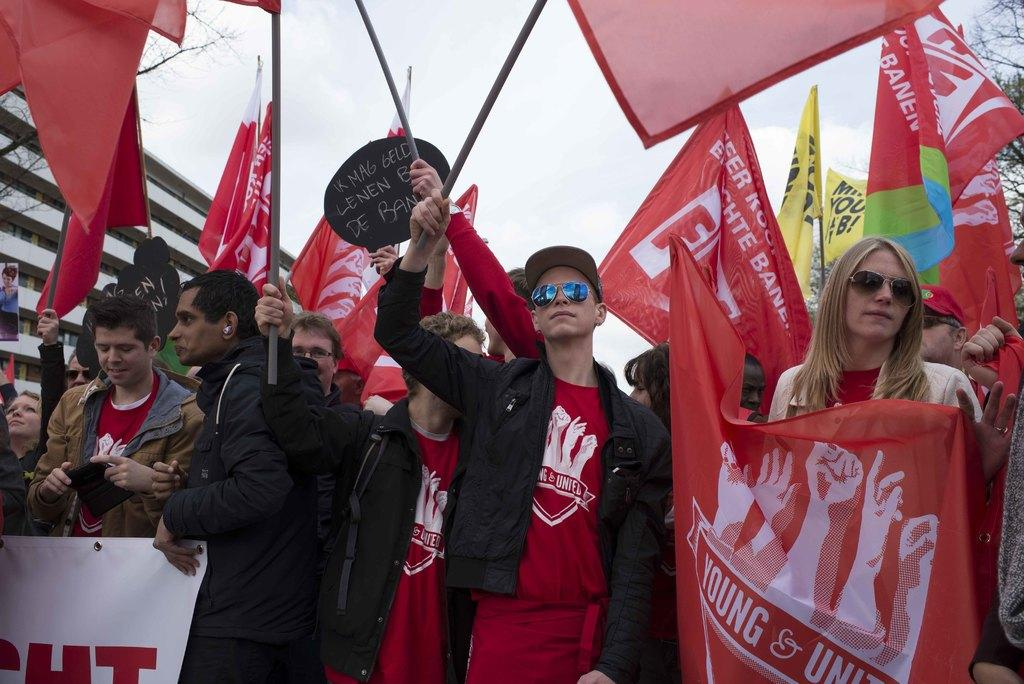What is the main subject of the image? The main subject of the image is a crowd. What are some people in the crowd wearing? Some people in the crowd are wearing goggles. What are some people in the crowd holding? Some people in the crowd are holding flags and banners. What can be seen in the background of the image? The sky, at least one building, and trees can be seen in the background of the image. What type of quartz can be seen in the image? There is no quartz present in the image. What is the distance between the crowd and the building in the image? The facts provided do not give any information about the distance between the crowd and the building, so it cannot be determined from the image. 